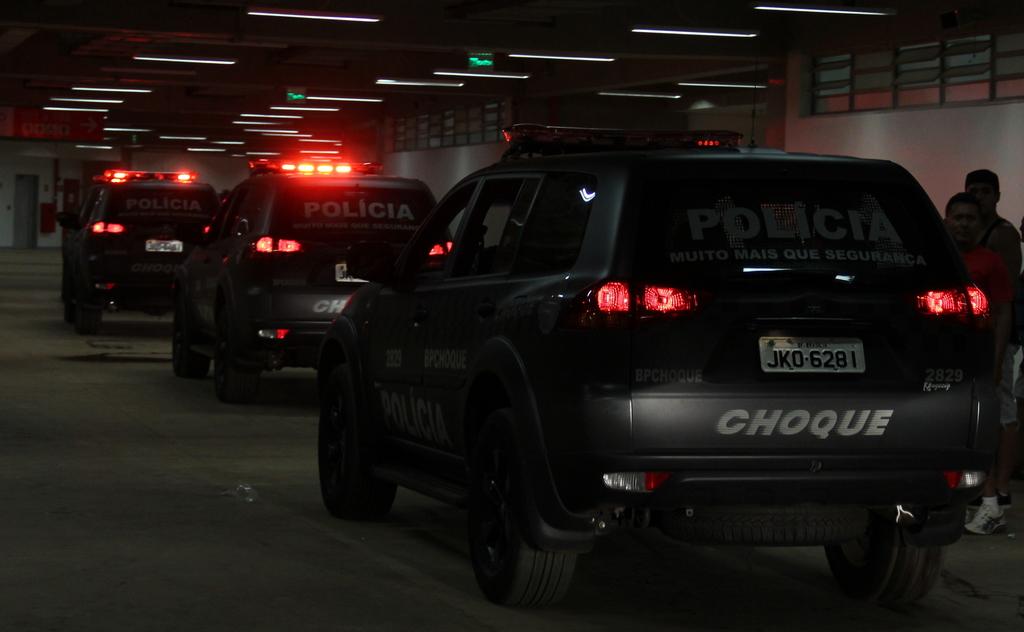What number is on the license plate?
Your answer should be compact. 6281. 